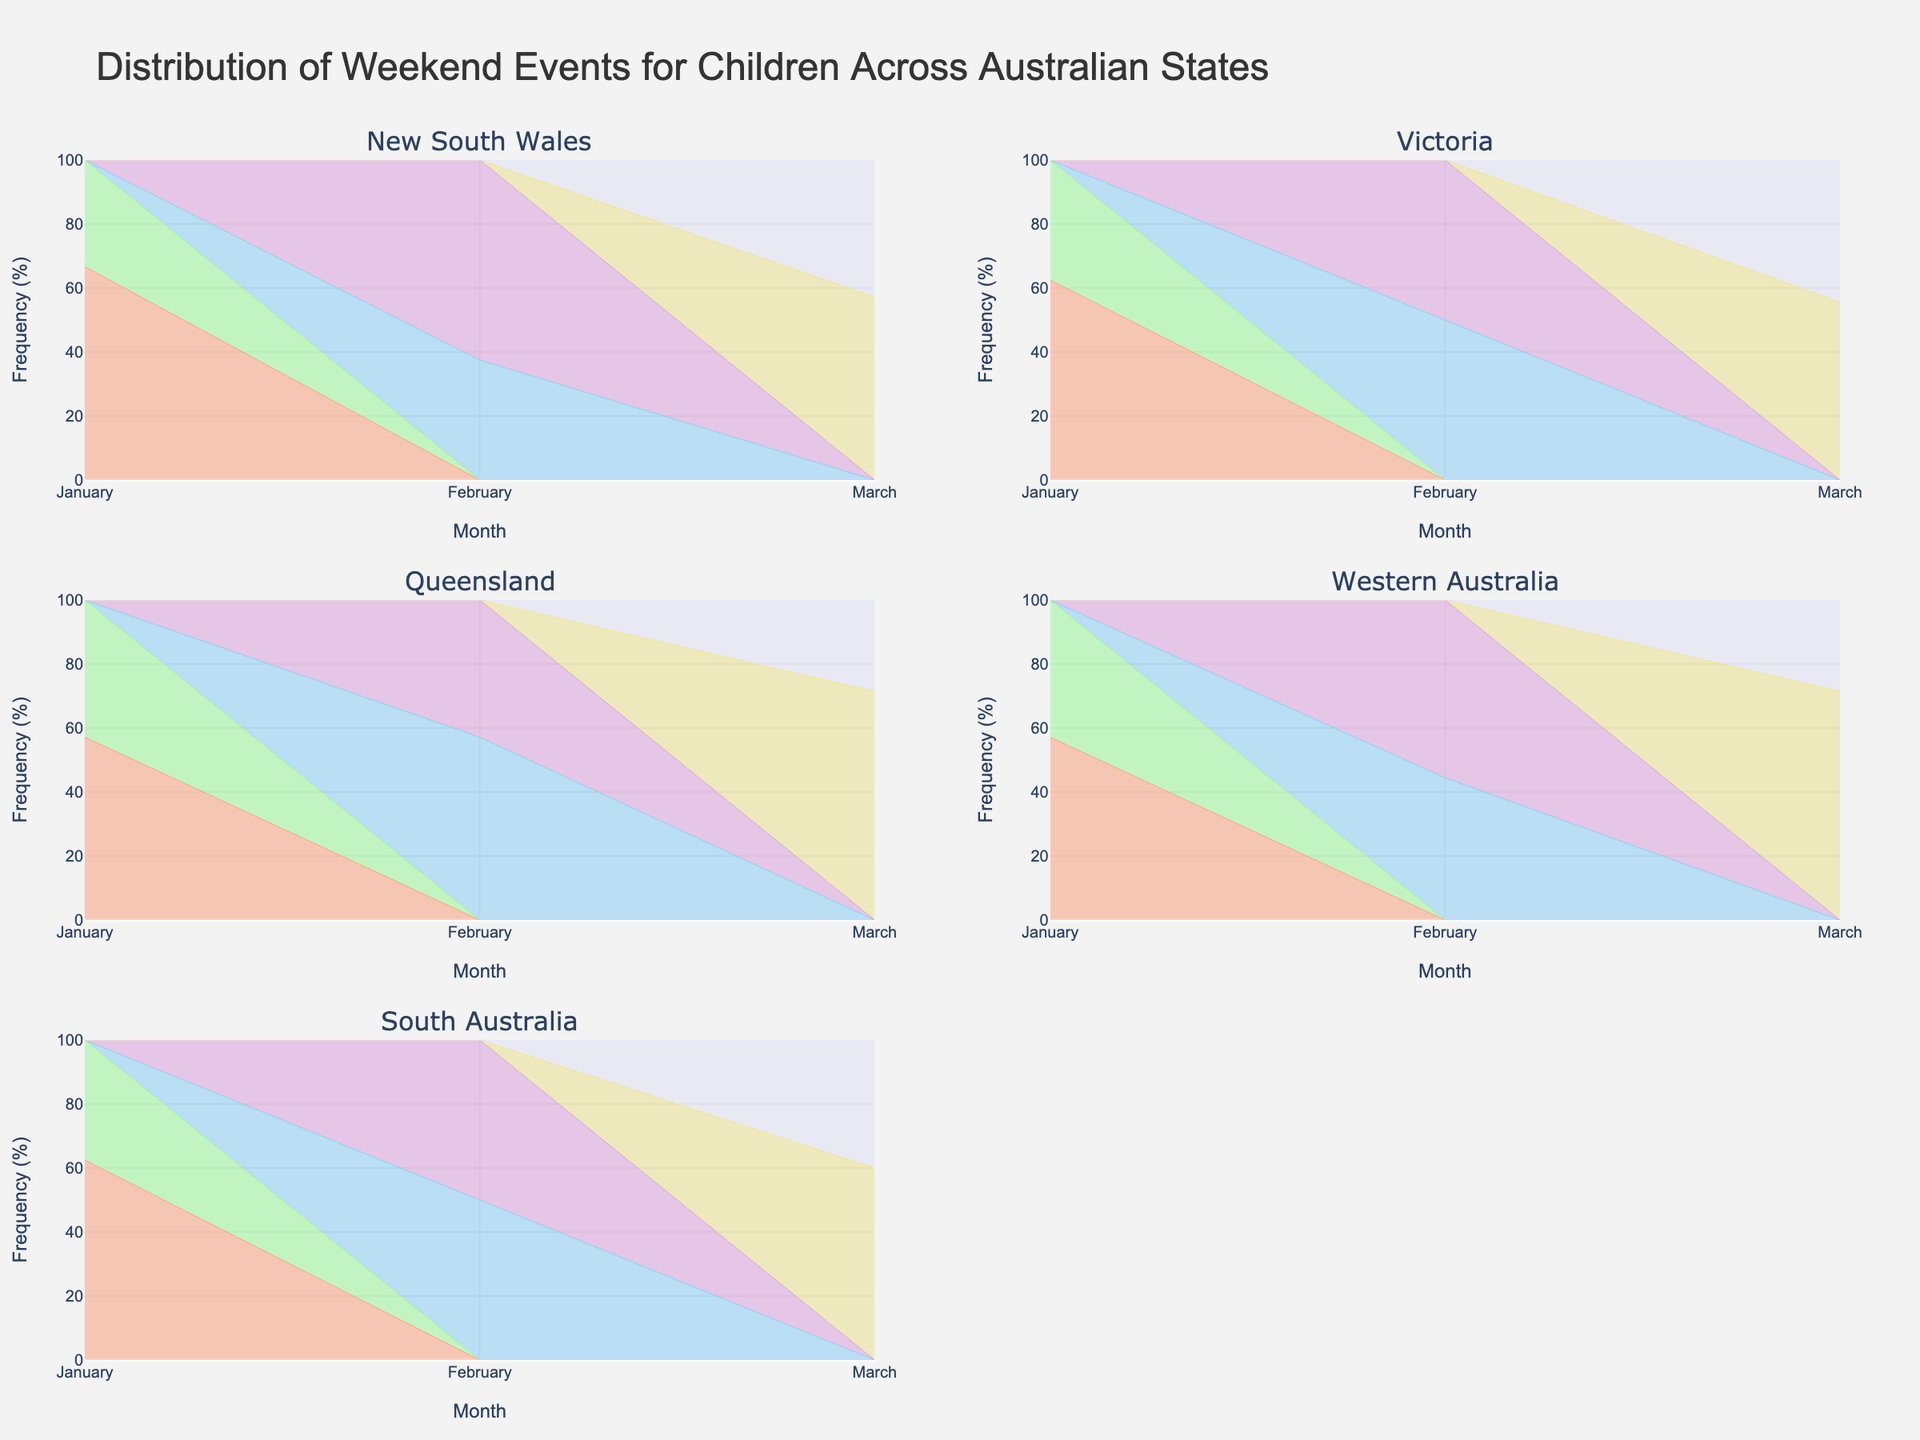What's the title of the figure? The title of the figure is prominently displayed at the top.
Answer: Distribution of Weekend Events for Children Across Australian States How many states are represented in the figure? Each subplot title represents a different state. By counting these titles, we can find the number of states.
Answer: 5 Which event has the highest frequency in New South Wales in March? In the New South Wales subplot, look at the colors corresponding to March and identify the tallest area segment.
Answer: Beach Fun Day What is the total frequency of events in Victoria in February? Sum the frequencies of all events in the Victoria subplot for February. These are Science Fair (4) and Storytelling Session (4). Adding these gives 8.
Answer: 8 Which event in Queensland in March has the lowest frequency? In the Queensland subplot, compare the heights of the area segments for March. The smallest one corresponds to Puppet Show.
Answer: Puppet Show What proportion of events in Western Australia in January is the Botanic Garden Tour? Examine the Western Australia subplot focusing on January, and compare the height of the Botanic Garden Tour area segment with the total height for January.
Answer: 4/7 Is the frequency of 'Outdoor Adventure' in January in Victoria higher or lower than 'Wildlife Safari' in January in New South Wales? Compare the heights of the corresponding area segments in January for both subplots. Outdoor Adventure in Victoria is taller (5 vs. 4).
Answer: Higher Which month has the highest total frequency of events in South Australia? Assess the areas covered in each month for the South Australia subplot. The month with the largest total area is January.
Answer: January Are there more types of events offered in February or March across all states? Count the unique events listed for February and March in the data for all states. There are more unique events in February (9) than in March (8).
Answer: February 